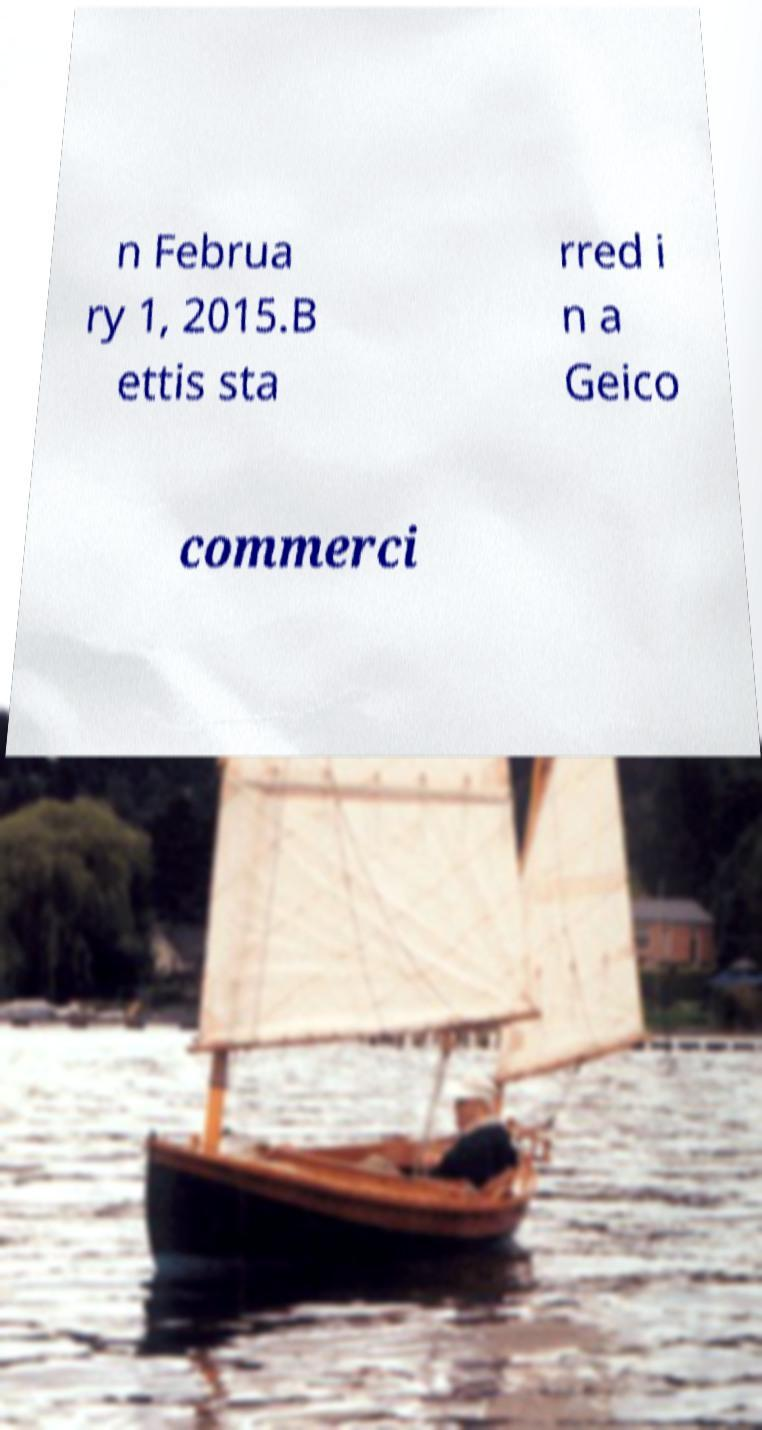Can you read and provide the text displayed in the image?This photo seems to have some interesting text. Can you extract and type it out for me? n Februa ry 1, 2015.B ettis sta rred i n a Geico commerci 